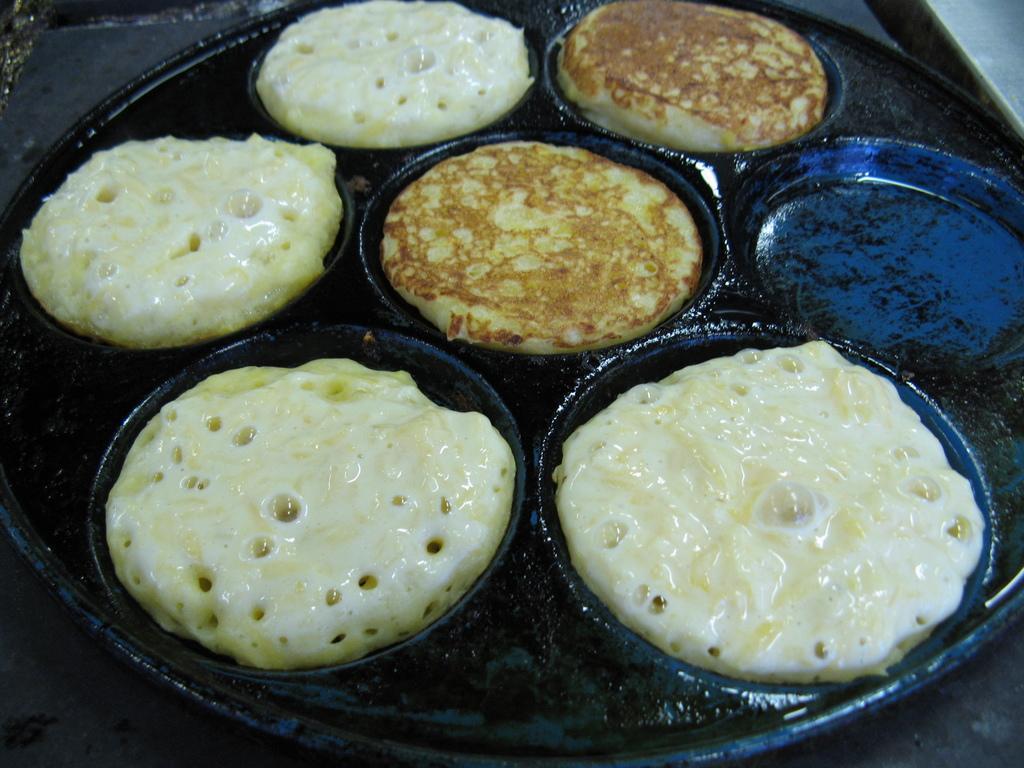Can you describe this image briefly? In this image I can see food items is being prepared on a metal plate. 